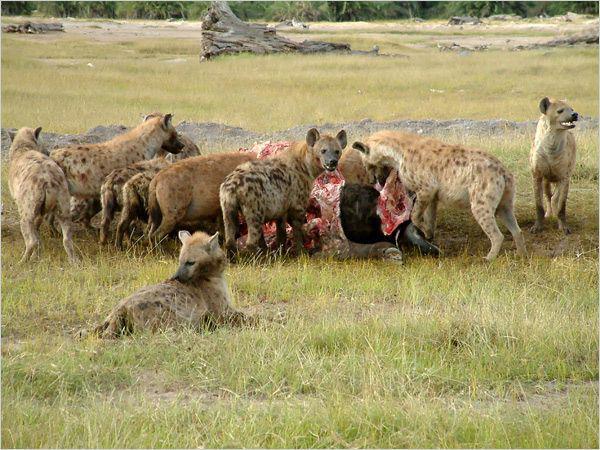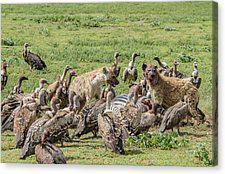The first image is the image on the left, the second image is the image on the right. Considering the images on both sides, is "One of the images contains birds along side the animals." valid? Answer yes or no. Yes. The first image is the image on the left, the second image is the image on the right. For the images shown, is this caption "Left image includes zebra in an image with hyena." true? Answer yes or no. No. 